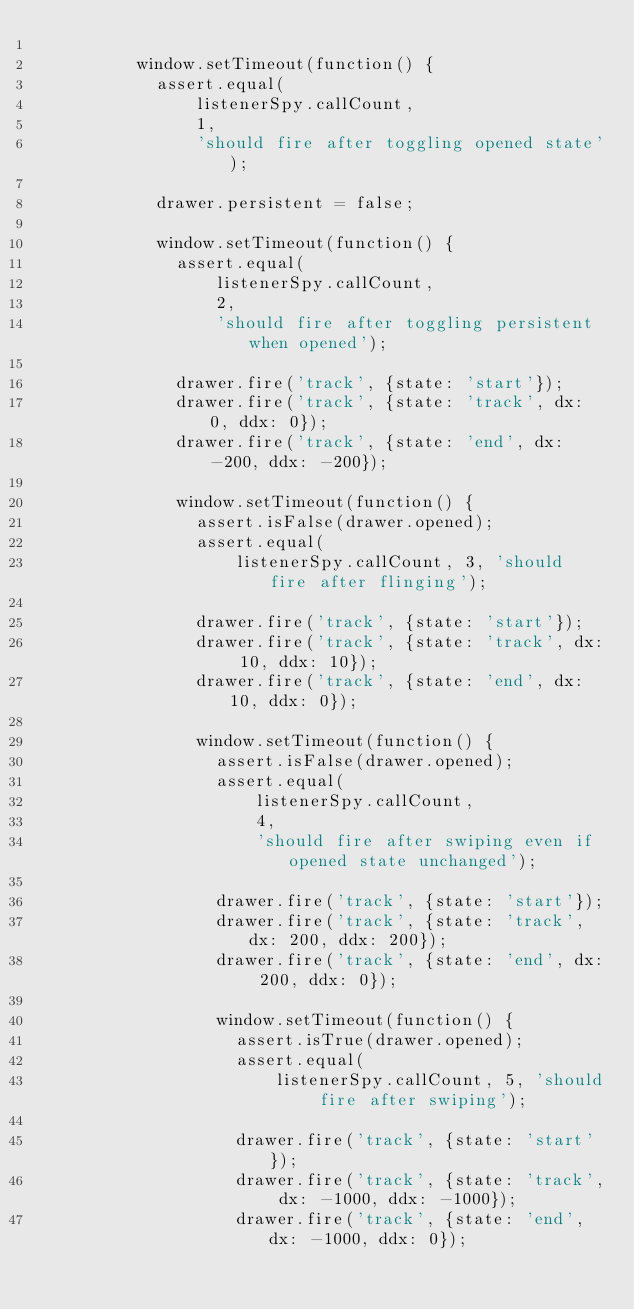Convert code to text. <code><loc_0><loc_0><loc_500><loc_500><_HTML_>
          window.setTimeout(function() {
            assert.equal(
                listenerSpy.callCount,
                1,
                'should fire after toggling opened state');

            drawer.persistent = false;

            window.setTimeout(function() {
              assert.equal(
                  listenerSpy.callCount,
                  2,
                  'should fire after toggling persistent when opened');

              drawer.fire('track', {state: 'start'});
              drawer.fire('track', {state: 'track', dx: 0, ddx: 0});
              drawer.fire('track', {state: 'end', dx: -200, ddx: -200});

              window.setTimeout(function() {
                assert.isFalse(drawer.opened);
                assert.equal(
                    listenerSpy.callCount, 3, 'should fire after flinging');

                drawer.fire('track', {state: 'start'});
                drawer.fire('track', {state: 'track', dx: 10, ddx: 10});
                drawer.fire('track', {state: 'end', dx: 10, ddx: 0});

                window.setTimeout(function() {
                  assert.isFalse(drawer.opened);
                  assert.equal(
                      listenerSpy.callCount,
                      4,
                      'should fire after swiping even if opened state unchanged');

                  drawer.fire('track', {state: 'start'});
                  drawer.fire('track', {state: 'track', dx: 200, ddx: 200});
                  drawer.fire('track', {state: 'end', dx: 200, ddx: 0});

                  window.setTimeout(function() {
                    assert.isTrue(drawer.opened);
                    assert.equal(
                        listenerSpy.callCount, 5, 'should fire after swiping');

                    drawer.fire('track', {state: 'start'});
                    drawer.fire('track', {state: 'track', dx: -1000, ddx: -1000});
                    drawer.fire('track', {state: 'end', dx: -1000, ddx: 0});
</code> 